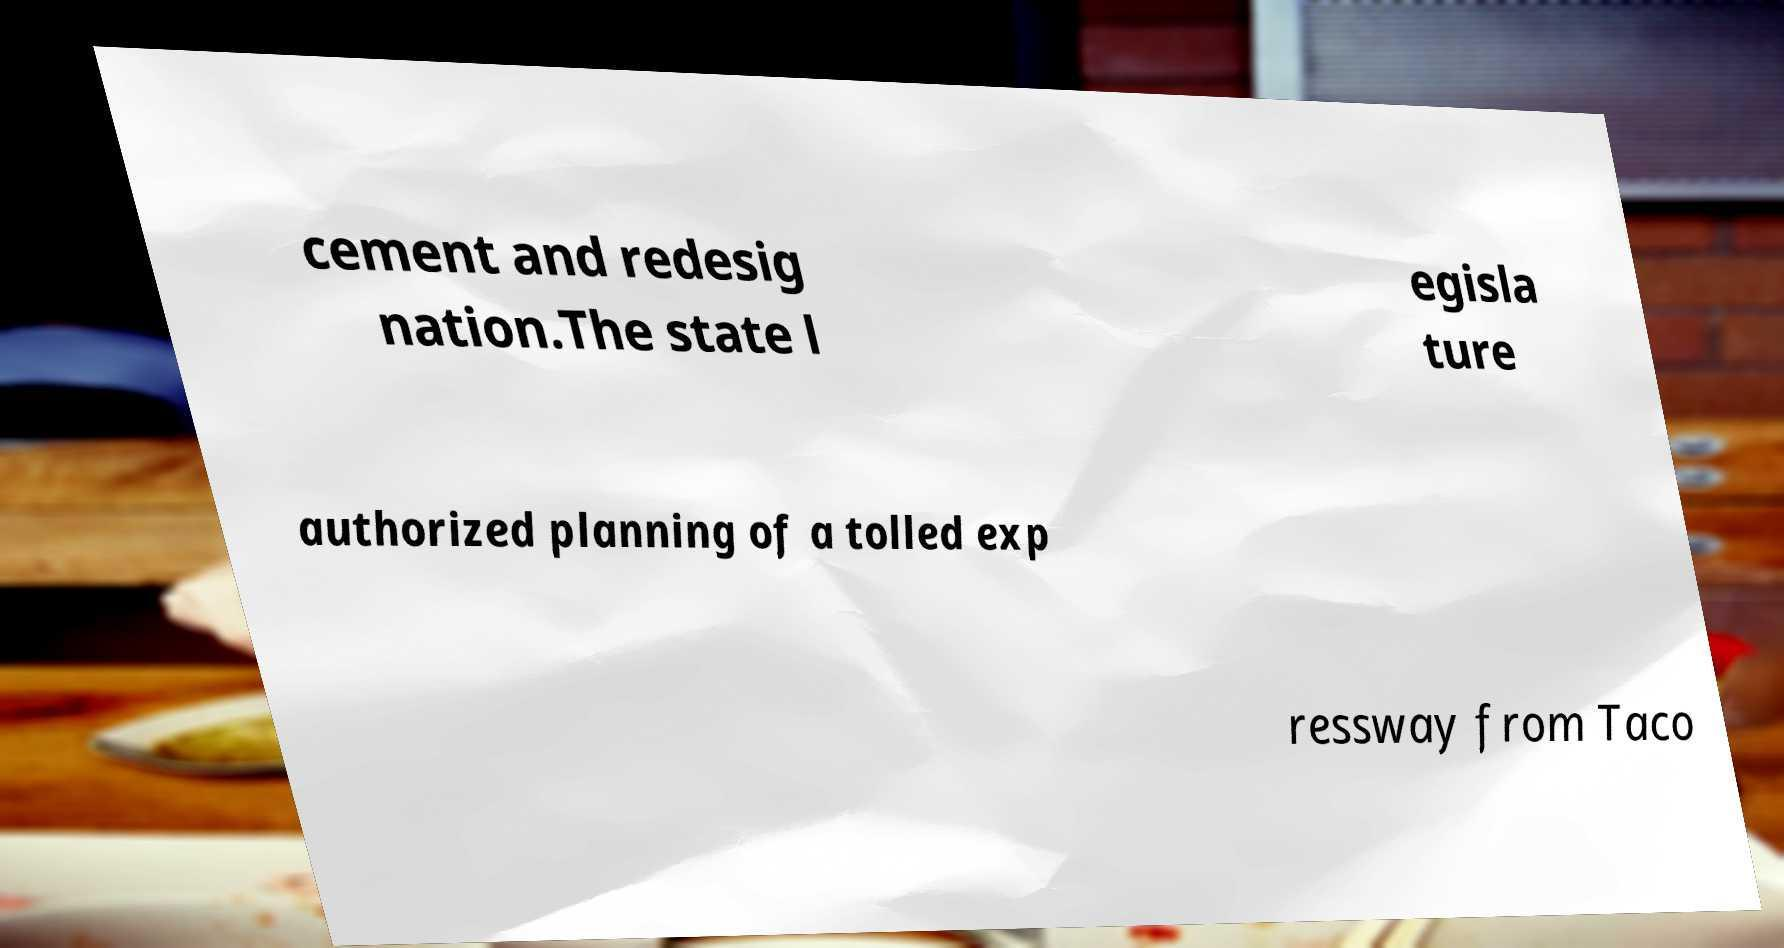There's text embedded in this image that I need extracted. Can you transcribe it verbatim? cement and redesig nation.The state l egisla ture authorized planning of a tolled exp ressway from Taco 